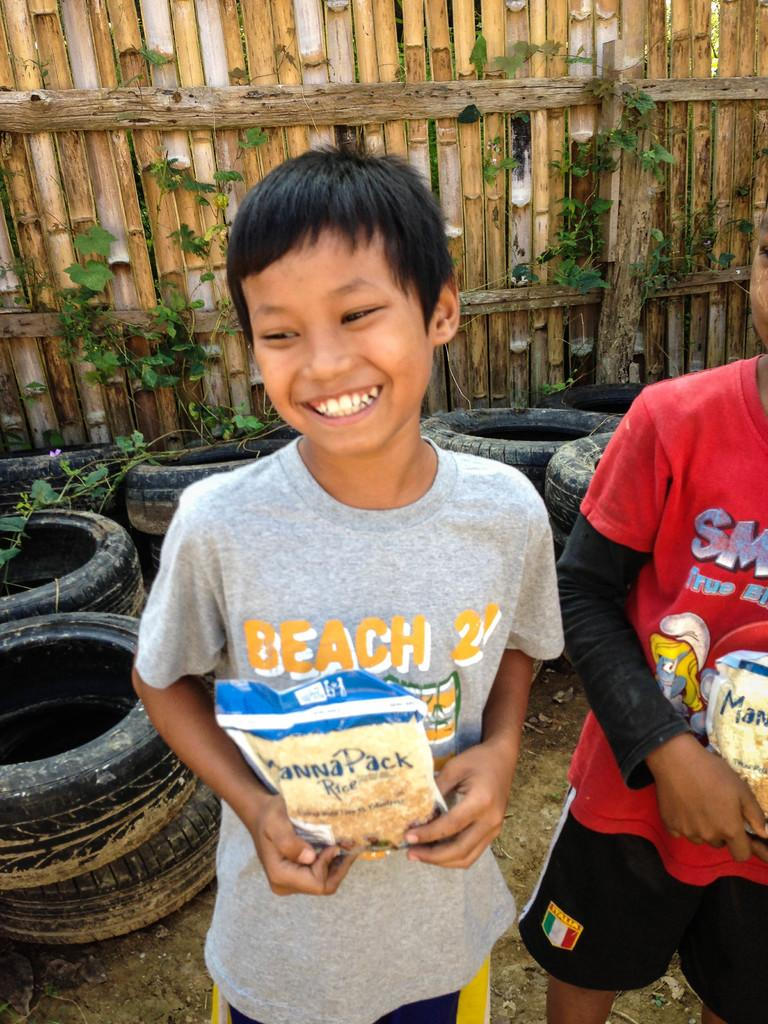How many boys are in the image? There are two boys in the image. What are the boys doing in the image? The boys are standing and holding packets. What can be seen in the background of the image? There are tires and a fence in the background of the image. What type of vegetation is present in the image? Creeper plants are present in the image. What flavor of kitten can be seen in the image? There is no kitten present in the image, so it is not possible to determine its flavor. 